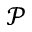Convert formula to latex. <formula><loc_0><loc_0><loc_500><loc_500>\mathcal { P }</formula> 